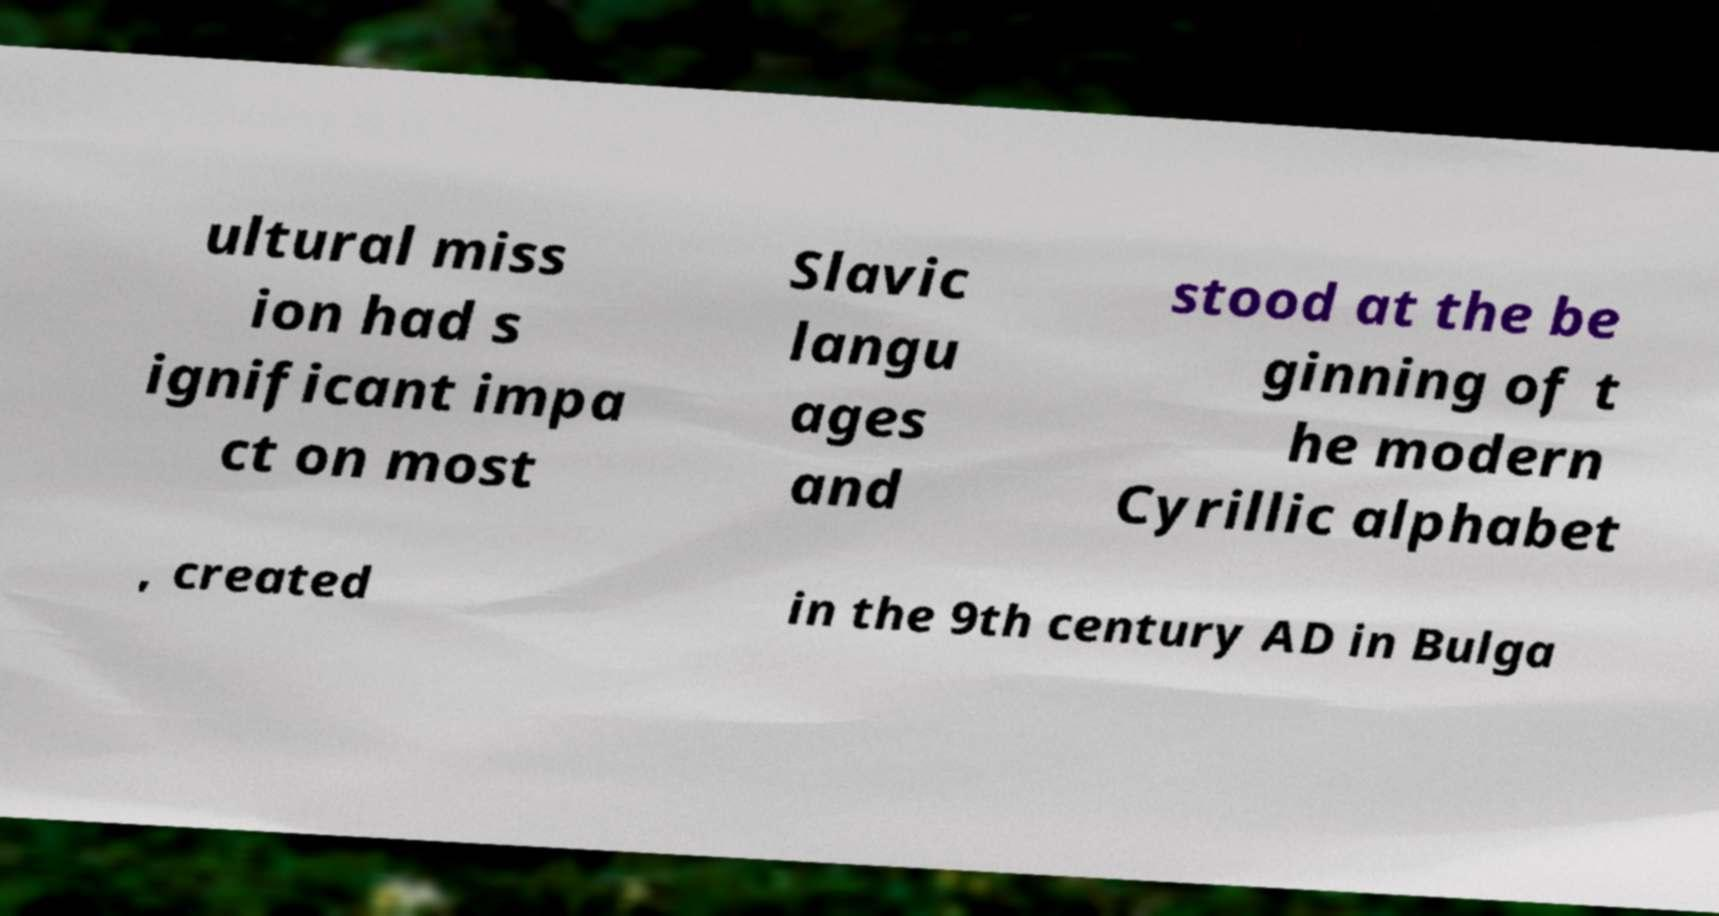For documentation purposes, I need the text within this image transcribed. Could you provide that? ultural miss ion had s ignificant impa ct on most Slavic langu ages and stood at the be ginning of t he modern Cyrillic alphabet , created in the 9th century AD in Bulga 